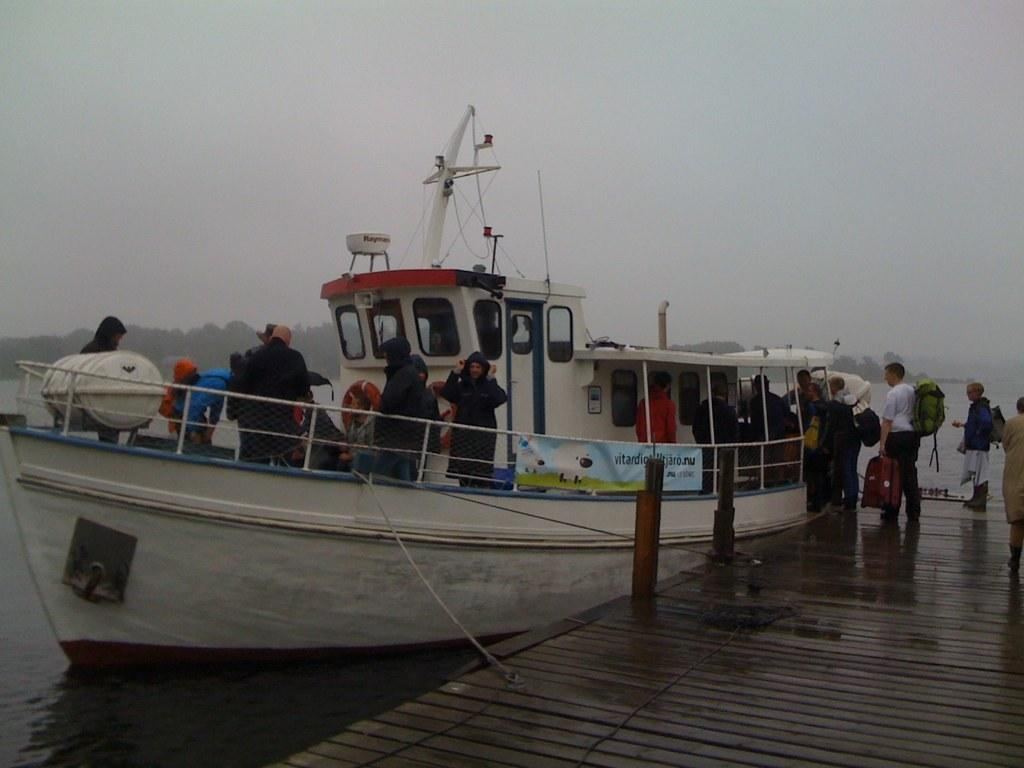What is the main subject in the foreground of the picture? There is a boat in the foreground of the picture. Where is the boat located in relation to the dock? The boat is near a dock. What can be seen in the background of the image? There is water, trees, and the sky visible in the background of the image. How many people are in the boat? There are persons in the boat. What type of branch is being used as an invention in the boat? There is no branch or invention present in the boat in the image. 